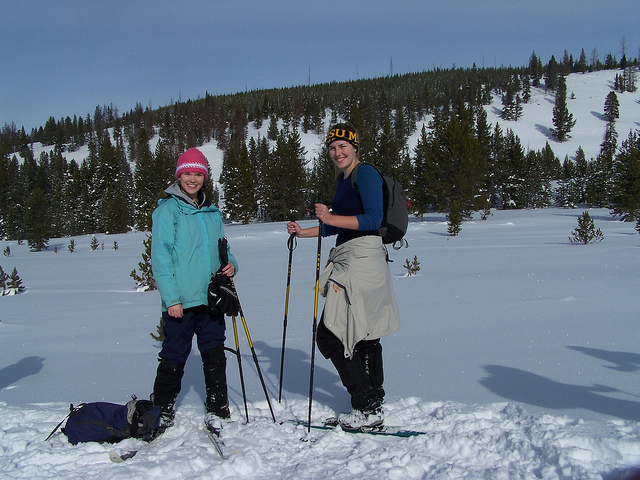<image>Which man has his skies facing a different way than the other men? It is ambiguous to identify which man has his skies facing a different way than the other men. Which man has his skies facing a different way than the other men? It is ambiguous to determine which man has his skies facing a different way than the other men. 